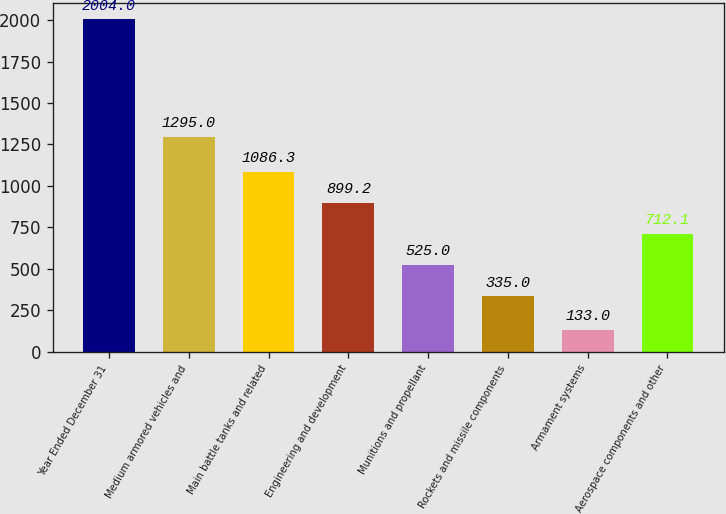Convert chart to OTSL. <chart><loc_0><loc_0><loc_500><loc_500><bar_chart><fcel>Year Ended December 31<fcel>Medium armored vehicles and<fcel>Main battle tanks and related<fcel>Engineering and development<fcel>Munitions and propellant<fcel>Rockets and missile components<fcel>Armament systems<fcel>Aerospace components and other<nl><fcel>2004<fcel>1295<fcel>1086.3<fcel>899.2<fcel>525<fcel>335<fcel>133<fcel>712.1<nl></chart> 